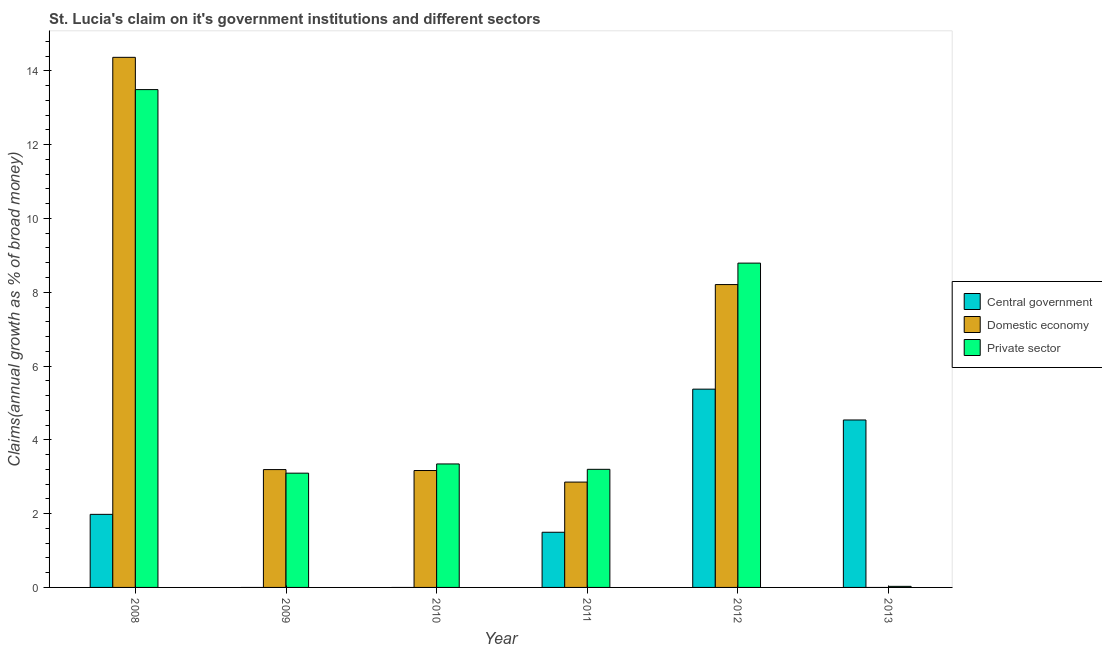Are the number of bars per tick equal to the number of legend labels?
Offer a very short reply. No. Are the number of bars on each tick of the X-axis equal?
Your response must be concise. No. How many bars are there on the 5th tick from the right?
Your answer should be compact. 2. What is the label of the 2nd group of bars from the left?
Keep it short and to the point. 2009. In how many cases, is the number of bars for a given year not equal to the number of legend labels?
Offer a very short reply. 3. What is the percentage of claim on the central government in 2010?
Your answer should be compact. 0. Across all years, what is the maximum percentage of claim on the domestic economy?
Ensure brevity in your answer.  14.37. In which year was the percentage of claim on the private sector maximum?
Offer a terse response. 2008. What is the total percentage of claim on the central government in the graph?
Make the answer very short. 13.39. What is the difference between the percentage of claim on the domestic economy in 2008 and that in 2011?
Offer a terse response. 11.51. What is the difference between the percentage of claim on the central government in 2013 and the percentage of claim on the private sector in 2008?
Provide a succinct answer. 2.56. What is the average percentage of claim on the private sector per year?
Offer a very short reply. 5.33. What is the ratio of the percentage of claim on the domestic economy in 2008 to that in 2010?
Provide a short and direct response. 4.53. What is the difference between the highest and the second highest percentage of claim on the private sector?
Provide a short and direct response. 4.7. What is the difference between the highest and the lowest percentage of claim on the private sector?
Offer a very short reply. 13.46. In how many years, is the percentage of claim on the domestic economy greater than the average percentage of claim on the domestic economy taken over all years?
Your answer should be very brief. 2. Is the sum of the percentage of claim on the domestic economy in 2010 and 2011 greater than the maximum percentage of claim on the private sector across all years?
Provide a succinct answer. No. Is it the case that in every year, the sum of the percentage of claim on the central government and percentage of claim on the domestic economy is greater than the percentage of claim on the private sector?
Keep it short and to the point. No. How many bars are there?
Provide a short and direct response. 15. Are the values on the major ticks of Y-axis written in scientific E-notation?
Offer a terse response. No. Does the graph contain grids?
Your response must be concise. No. Where does the legend appear in the graph?
Make the answer very short. Center right. What is the title of the graph?
Provide a short and direct response. St. Lucia's claim on it's government institutions and different sectors. Does "Ages 20-60" appear as one of the legend labels in the graph?
Keep it short and to the point. No. What is the label or title of the Y-axis?
Offer a terse response. Claims(annual growth as % of broad money). What is the Claims(annual growth as % of broad money) of Central government in 2008?
Provide a short and direct response. 1.98. What is the Claims(annual growth as % of broad money) of Domestic economy in 2008?
Ensure brevity in your answer.  14.37. What is the Claims(annual growth as % of broad money) in Private sector in 2008?
Your response must be concise. 13.49. What is the Claims(annual growth as % of broad money) in Domestic economy in 2009?
Offer a terse response. 3.19. What is the Claims(annual growth as % of broad money) in Private sector in 2009?
Offer a very short reply. 3.1. What is the Claims(annual growth as % of broad money) of Domestic economy in 2010?
Offer a terse response. 3.17. What is the Claims(annual growth as % of broad money) in Private sector in 2010?
Your answer should be compact. 3.35. What is the Claims(annual growth as % of broad money) of Central government in 2011?
Ensure brevity in your answer.  1.5. What is the Claims(annual growth as % of broad money) of Domestic economy in 2011?
Provide a short and direct response. 2.86. What is the Claims(annual growth as % of broad money) in Private sector in 2011?
Your answer should be very brief. 3.2. What is the Claims(annual growth as % of broad money) in Central government in 2012?
Keep it short and to the point. 5.37. What is the Claims(annual growth as % of broad money) in Domestic economy in 2012?
Give a very brief answer. 8.21. What is the Claims(annual growth as % of broad money) in Private sector in 2012?
Offer a terse response. 8.79. What is the Claims(annual growth as % of broad money) in Central government in 2013?
Keep it short and to the point. 4.54. What is the Claims(annual growth as % of broad money) in Private sector in 2013?
Your response must be concise. 0.03. Across all years, what is the maximum Claims(annual growth as % of broad money) of Central government?
Your response must be concise. 5.37. Across all years, what is the maximum Claims(annual growth as % of broad money) in Domestic economy?
Provide a short and direct response. 14.37. Across all years, what is the maximum Claims(annual growth as % of broad money) in Private sector?
Offer a terse response. 13.49. Across all years, what is the minimum Claims(annual growth as % of broad money) in Domestic economy?
Make the answer very short. 0. Across all years, what is the minimum Claims(annual growth as % of broad money) in Private sector?
Give a very brief answer. 0.03. What is the total Claims(annual growth as % of broad money) in Central government in the graph?
Keep it short and to the point. 13.39. What is the total Claims(annual growth as % of broad money) of Domestic economy in the graph?
Ensure brevity in your answer.  31.79. What is the total Claims(annual growth as % of broad money) of Private sector in the graph?
Provide a succinct answer. 31.96. What is the difference between the Claims(annual growth as % of broad money) in Domestic economy in 2008 and that in 2009?
Your response must be concise. 11.17. What is the difference between the Claims(annual growth as % of broad money) in Private sector in 2008 and that in 2009?
Offer a very short reply. 10.4. What is the difference between the Claims(annual growth as % of broad money) in Domestic economy in 2008 and that in 2010?
Your answer should be very brief. 11.2. What is the difference between the Claims(annual growth as % of broad money) of Private sector in 2008 and that in 2010?
Offer a very short reply. 10.15. What is the difference between the Claims(annual growth as % of broad money) in Central government in 2008 and that in 2011?
Give a very brief answer. 0.49. What is the difference between the Claims(annual growth as % of broad money) in Domestic economy in 2008 and that in 2011?
Offer a terse response. 11.51. What is the difference between the Claims(annual growth as % of broad money) in Private sector in 2008 and that in 2011?
Offer a very short reply. 10.29. What is the difference between the Claims(annual growth as % of broad money) in Central government in 2008 and that in 2012?
Your response must be concise. -3.39. What is the difference between the Claims(annual growth as % of broad money) of Domestic economy in 2008 and that in 2012?
Your answer should be compact. 6.16. What is the difference between the Claims(annual growth as % of broad money) of Private sector in 2008 and that in 2012?
Ensure brevity in your answer.  4.7. What is the difference between the Claims(annual growth as % of broad money) in Central government in 2008 and that in 2013?
Offer a very short reply. -2.56. What is the difference between the Claims(annual growth as % of broad money) in Private sector in 2008 and that in 2013?
Make the answer very short. 13.46. What is the difference between the Claims(annual growth as % of broad money) in Domestic economy in 2009 and that in 2010?
Offer a very short reply. 0.03. What is the difference between the Claims(annual growth as % of broad money) in Private sector in 2009 and that in 2010?
Your response must be concise. -0.25. What is the difference between the Claims(annual growth as % of broad money) in Domestic economy in 2009 and that in 2011?
Offer a terse response. 0.34. What is the difference between the Claims(annual growth as % of broad money) in Private sector in 2009 and that in 2011?
Keep it short and to the point. -0.1. What is the difference between the Claims(annual growth as % of broad money) of Domestic economy in 2009 and that in 2012?
Make the answer very short. -5.01. What is the difference between the Claims(annual growth as % of broad money) of Private sector in 2009 and that in 2012?
Ensure brevity in your answer.  -5.69. What is the difference between the Claims(annual growth as % of broad money) in Private sector in 2009 and that in 2013?
Ensure brevity in your answer.  3.07. What is the difference between the Claims(annual growth as % of broad money) in Domestic economy in 2010 and that in 2011?
Offer a very short reply. 0.31. What is the difference between the Claims(annual growth as % of broad money) in Private sector in 2010 and that in 2011?
Your answer should be very brief. 0.15. What is the difference between the Claims(annual growth as % of broad money) of Domestic economy in 2010 and that in 2012?
Your answer should be very brief. -5.04. What is the difference between the Claims(annual growth as % of broad money) of Private sector in 2010 and that in 2012?
Provide a short and direct response. -5.44. What is the difference between the Claims(annual growth as % of broad money) of Private sector in 2010 and that in 2013?
Your response must be concise. 3.32. What is the difference between the Claims(annual growth as % of broad money) in Central government in 2011 and that in 2012?
Offer a terse response. -3.88. What is the difference between the Claims(annual growth as % of broad money) in Domestic economy in 2011 and that in 2012?
Your answer should be very brief. -5.35. What is the difference between the Claims(annual growth as % of broad money) in Private sector in 2011 and that in 2012?
Offer a terse response. -5.59. What is the difference between the Claims(annual growth as % of broad money) of Central government in 2011 and that in 2013?
Your answer should be compact. -3.04. What is the difference between the Claims(annual growth as % of broad money) of Private sector in 2011 and that in 2013?
Keep it short and to the point. 3.17. What is the difference between the Claims(annual growth as % of broad money) of Central government in 2012 and that in 2013?
Your answer should be very brief. 0.84. What is the difference between the Claims(annual growth as % of broad money) in Private sector in 2012 and that in 2013?
Your answer should be very brief. 8.76. What is the difference between the Claims(annual growth as % of broad money) of Central government in 2008 and the Claims(annual growth as % of broad money) of Domestic economy in 2009?
Make the answer very short. -1.21. What is the difference between the Claims(annual growth as % of broad money) of Central government in 2008 and the Claims(annual growth as % of broad money) of Private sector in 2009?
Keep it short and to the point. -1.12. What is the difference between the Claims(annual growth as % of broad money) in Domestic economy in 2008 and the Claims(annual growth as % of broad money) in Private sector in 2009?
Provide a succinct answer. 11.27. What is the difference between the Claims(annual growth as % of broad money) in Central government in 2008 and the Claims(annual growth as % of broad money) in Domestic economy in 2010?
Ensure brevity in your answer.  -1.19. What is the difference between the Claims(annual growth as % of broad money) of Central government in 2008 and the Claims(annual growth as % of broad money) of Private sector in 2010?
Provide a short and direct response. -1.37. What is the difference between the Claims(annual growth as % of broad money) of Domestic economy in 2008 and the Claims(annual growth as % of broad money) of Private sector in 2010?
Give a very brief answer. 11.02. What is the difference between the Claims(annual growth as % of broad money) of Central government in 2008 and the Claims(annual growth as % of broad money) of Domestic economy in 2011?
Provide a short and direct response. -0.87. What is the difference between the Claims(annual growth as % of broad money) in Central government in 2008 and the Claims(annual growth as % of broad money) in Private sector in 2011?
Make the answer very short. -1.22. What is the difference between the Claims(annual growth as % of broad money) of Domestic economy in 2008 and the Claims(annual growth as % of broad money) of Private sector in 2011?
Your answer should be very brief. 11.17. What is the difference between the Claims(annual growth as % of broad money) in Central government in 2008 and the Claims(annual growth as % of broad money) in Domestic economy in 2012?
Give a very brief answer. -6.23. What is the difference between the Claims(annual growth as % of broad money) in Central government in 2008 and the Claims(annual growth as % of broad money) in Private sector in 2012?
Give a very brief answer. -6.81. What is the difference between the Claims(annual growth as % of broad money) of Domestic economy in 2008 and the Claims(annual growth as % of broad money) of Private sector in 2012?
Your response must be concise. 5.58. What is the difference between the Claims(annual growth as % of broad money) of Central government in 2008 and the Claims(annual growth as % of broad money) of Private sector in 2013?
Your answer should be very brief. 1.95. What is the difference between the Claims(annual growth as % of broad money) in Domestic economy in 2008 and the Claims(annual growth as % of broad money) in Private sector in 2013?
Keep it short and to the point. 14.34. What is the difference between the Claims(annual growth as % of broad money) in Domestic economy in 2009 and the Claims(annual growth as % of broad money) in Private sector in 2010?
Your response must be concise. -0.15. What is the difference between the Claims(annual growth as % of broad money) in Domestic economy in 2009 and the Claims(annual growth as % of broad money) in Private sector in 2011?
Give a very brief answer. -0.01. What is the difference between the Claims(annual growth as % of broad money) of Domestic economy in 2009 and the Claims(annual growth as % of broad money) of Private sector in 2012?
Offer a very short reply. -5.6. What is the difference between the Claims(annual growth as % of broad money) in Domestic economy in 2009 and the Claims(annual growth as % of broad money) in Private sector in 2013?
Offer a terse response. 3.17. What is the difference between the Claims(annual growth as % of broad money) in Domestic economy in 2010 and the Claims(annual growth as % of broad money) in Private sector in 2011?
Offer a terse response. -0.03. What is the difference between the Claims(annual growth as % of broad money) of Domestic economy in 2010 and the Claims(annual growth as % of broad money) of Private sector in 2012?
Offer a very short reply. -5.62. What is the difference between the Claims(annual growth as % of broad money) in Domestic economy in 2010 and the Claims(annual growth as % of broad money) in Private sector in 2013?
Give a very brief answer. 3.14. What is the difference between the Claims(annual growth as % of broad money) of Central government in 2011 and the Claims(annual growth as % of broad money) of Domestic economy in 2012?
Ensure brevity in your answer.  -6.71. What is the difference between the Claims(annual growth as % of broad money) of Central government in 2011 and the Claims(annual growth as % of broad money) of Private sector in 2012?
Give a very brief answer. -7.29. What is the difference between the Claims(annual growth as % of broad money) of Domestic economy in 2011 and the Claims(annual growth as % of broad money) of Private sector in 2012?
Your answer should be very brief. -5.93. What is the difference between the Claims(annual growth as % of broad money) of Central government in 2011 and the Claims(annual growth as % of broad money) of Private sector in 2013?
Ensure brevity in your answer.  1.47. What is the difference between the Claims(annual growth as % of broad money) in Domestic economy in 2011 and the Claims(annual growth as % of broad money) in Private sector in 2013?
Provide a succinct answer. 2.83. What is the difference between the Claims(annual growth as % of broad money) of Central government in 2012 and the Claims(annual growth as % of broad money) of Private sector in 2013?
Keep it short and to the point. 5.34. What is the difference between the Claims(annual growth as % of broad money) in Domestic economy in 2012 and the Claims(annual growth as % of broad money) in Private sector in 2013?
Ensure brevity in your answer.  8.18. What is the average Claims(annual growth as % of broad money) in Central government per year?
Ensure brevity in your answer.  2.23. What is the average Claims(annual growth as % of broad money) in Domestic economy per year?
Make the answer very short. 5.3. What is the average Claims(annual growth as % of broad money) in Private sector per year?
Provide a succinct answer. 5.33. In the year 2008, what is the difference between the Claims(annual growth as % of broad money) of Central government and Claims(annual growth as % of broad money) of Domestic economy?
Ensure brevity in your answer.  -12.39. In the year 2008, what is the difference between the Claims(annual growth as % of broad money) in Central government and Claims(annual growth as % of broad money) in Private sector?
Provide a succinct answer. -11.51. In the year 2008, what is the difference between the Claims(annual growth as % of broad money) in Domestic economy and Claims(annual growth as % of broad money) in Private sector?
Provide a succinct answer. 0.87. In the year 2009, what is the difference between the Claims(annual growth as % of broad money) in Domestic economy and Claims(annual growth as % of broad money) in Private sector?
Keep it short and to the point. 0.1. In the year 2010, what is the difference between the Claims(annual growth as % of broad money) of Domestic economy and Claims(annual growth as % of broad money) of Private sector?
Make the answer very short. -0.18. In the year 2011, what is the difference between the Claims(annual growth as % of broad money) of Central government and Claims(annual growth as % of broad money) of Domestic economy?
Offer a very short reply. -1.36. In the year 2011, what is the difference between the Claims(annual growth as % of broad money) in Central government and Claims(annual growth as % of broad money) in Private sector?
Ensure brevity in your answer.  -1.71. In the year 2011, what is the difference between the Claims(annual growth as % of broad money) of Domestic economy and Claims(annual growth as % of broad money) of Private sector?
Give a very brief answer. -0.35. In the year 2012, what is the difference between the Claims(annual growth as % of broad money) in Central government and Claims(annual growth as % of broad money) in Domestic economy?
Offer a terse response. -2.83. In the year 2012, what is the difference between the Claims(annual growth as % of broad money) in Central government and Claims(annual growth as % of broad money) in Private sector?
Give a very brief answer. -3.42. In the year 2012, what is the difference between the Claims(annual growth as % of broad money) in Domestic economy and Claims(annual growth as % of broad money) in Private sector?
Provide a succinct answer. -0.58. In the year 2013, what is the difference between the Claims(annual growth as % of broad money) of Central government and Claims(annual growth as % of broad money) of Private sector?
Give a very brief answer. 4.51. What is the ratio of the Claims(annual growth as % of broad money) of Domestic economy in 2008 to that in 2009?
Offer a very short reply. 4.5. What is the ratio of the Claims(annual growth as % of broad money) of Private sector in 2008 to that in 2009?
Give a very brief answer. 4.36. What is the ratio of the Claims(annual growth as % of broad money) of Domestic economy in 2008 to that in 2010?
Offer a terse response. 4.53. What is the ratio of the Claims(annual growth as % of broad money) of Private sector in 2008 to that in 2010?
Give a very brief answer. 4.03. What is the ratio of the Claims(annual growth as % of broad money) of Central government in 2008 to that in 2011?
Offer a very short reply. 1.32. What is the ratio of the Claims(annual growth as % of broad money) in Domestic economy in 2008 to that in 2011?
Make the answer very short. 5.03. What is the ratio of the Claims(annual growth as % of broad money) of Private sector in 2008 to that in 2011?
Make the answer very short. 4.22. What is the ratio of the Claims(annual growth as % of broad money) of Central government in 2008 to that in 2012?
Your answer should be compact. 0.37. What is the ratio of the Claims(annual growth as % of broad money) in Domestic economy in 2008 to that in 2012?
Your answer should be very brief. 1.75. What is the ratio of the Claims(annual growth as % of broad money) in Private sector in 2008 to that in 2012?
Give a very brief answer. 1.53. What is the ratio of the Claims(annual growth as % of broad money) of Central government in 2008 to that in 2013?
Your answer should be very brief. 0.44. What is the ratio of the Claims(annual growth as % of broad money) in Private sector in 2008 to that in 2013?
Keep it short and to the point. 462.91. What is the ratio of the Claims(annual growth as % of broad money) of Private sector in 2009 to that in 2010?
Keep it short and to the point. 0.93. What is the ratio of the Claims(annual growth as % of broad money) in Domestic economy in 2009 to that in 2011?
Offer a very short reply. 1.12. What is the ratio of the Claims(annual growth as % of broad money) in Private sector in 2009 to that in 2011?
Offer a very short reply. 0.97. What is the ratio of the Claims(annual growth as % of broad money) of Domestic economy in 2009 to that in 2012?
Provide a short and direct response. 0.39. What is the ratio of the Claims(annual growth as % of broad money) in Private sector in 2009 to that in 2012?
Give a very brief answer. 0.35. What is the ratio of the Claims(annual growth as % of broad money) of Private sector in 2009 to that in 2013?
Your answer should be compact. 106.25. What is the ratio of the Claims(annual growth as % of broad money) of Domestic economy in 2010 to that in 2011?
Your answer should be compact. 1.11. What is the ratio of the Claims(annual growth as % of broad money) of Private sector in 2010 to that in 2011?
Provide a short and direct response. 1.05. What is the ratio of the Claims(annual growth as % of broad money) of Domestic economy in 2010 to that in 2012?
Provide a succinct answer. 0.39. What is the ratio of the Claims(annual growth as % of broad money) of Private sector in 2010 to that in 2012?
Make the answer very short. 0.38. What is the ratio of the Claims(annual growth as % of broad money) in Private sector in 2010 to that in 2013?
Keep it short and to the point. 114.82. What is the ratio of the Claims(annual growth as % of broad money) in Central government in 2011 to that in 2012?
Make the answer very short. 0.28. What is the ratio of the Claims(annual growth as % of broad money) in Domestic economy in 2011 to that in 2012?
Make the answer very short. 0.35. What is the ratio of the Claims(annual growth as % of broad money) of Private sector in 2011 to that in 2012?
Make the answer very short. 0.36. What is the ratio of the Claims(annual growth as % of broad money) in Central government in 2011 to that in 2013?
Make the answer very short. 0.33. What is the ratio of the Claims(annual growth as % of broad money) in Private sector in 2011 to that in 2013?
Ensure brevity in your answer.  109.82. What is the ratio of the Claims(annual growth as % of broad money) of Central government in 2012 to that in 2013?
Your response must be concise. 1.18. What is the ratio of the Claims(annual growth as % of broad money) in Private sector in 2012 to that in 2013?
Offer a very short reply. 301.57. What is the difference between the highest and the second highest Claims(annual growth as % of broad money) of Central government?
Offer a terse response. 0.84. What is the difference between the highest and the second highest Claims(annual growth as % of broad money) in Domestic economy?
Give a very brief answer. 6.16. What is the difference between the highest and the second highest Claims(annual growth as % of broad money) in Private sector?
Keep it short and to the point. 4.7. What is the difference between the highest and the lowest Claims(annual growth as % of broad money) of Central government?
Your response must be concise. 5.37. What is the difference between the highest and the lowest Claims(annual growth as % of broad money) of Domestic economy?
Make the answer very short. 14.37. What is the difference between the highest and the lowest Claims(annual growth as % of broad money) in Private sector?
Ensure brevity in your answer.  13.46. 